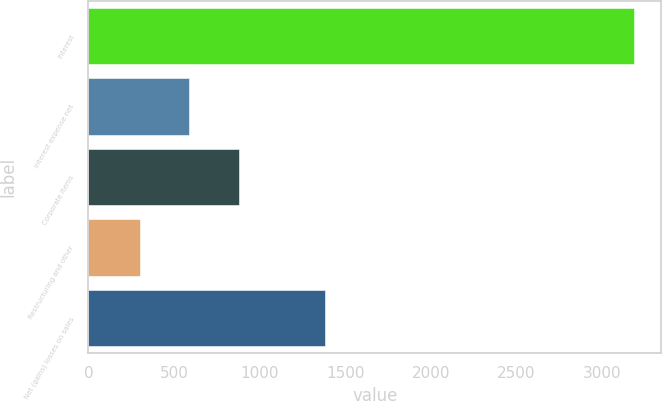<chart> <loc_0><loc_0><loc_500><loc_500><bar_chart><fcel>Interest<fcel>Interest expense net<fcel>Corporate items<fcel>Restructuring and other<fcel>Net (gains) losses on sales<nl><fcel>3188<fcel>588.8<fcel>877.6<fcel>300<fcel>1381<nl></chart> 